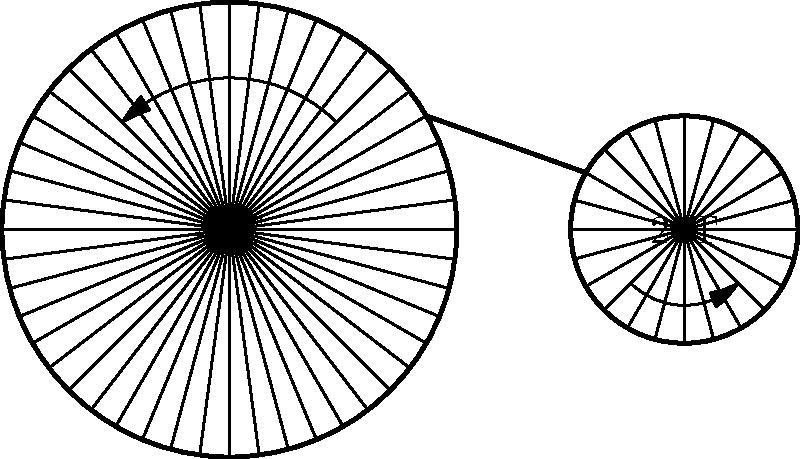Given the bicycle gear system shown in the schematic, with a 48-tooth chainring and a 24-tooth rear sprocket, calculate the gear ratio. How would this ratio affect a cyclist's performance on a flat road versus a steep climb? To solve this problem, let's follow these steps:

1. Calculate the gear ratio:
   The gear ratio is determined by dividing the number of teeth on the chainring by the number of teeth on the rear sprocket.

   Gear ratio = $\frac{\text{Teeth on chainring}}{\text{Teeth on rear sprocket}} = \frac{48}{24} = 2$

2. Understand the meaning of the gear ratio:
   A gear ratio of 2 means that for every complete revolution of the pedals (chainring), the rear wheel will rotate twice.

3. Effect on flat road:
   - Higher gear ratios provide more speed for each pedal revolution.
   - On a flat road, a 2:1 ratio would allow the cyclist to maintain high speeds with less cadence (pedaling frequency).
   - This is beneficial for experienced riders who can generate significant power.

4. Effect on steep climb:
   - Higher gear ratios require more force to turn the pedals.
   - On a steep climb, a 2:1 ratio would be challenging as it requires more strength per pedal stroke.
   - Climbers often prefer lower gear ratios (closer to 1:1) for easier pedaling on inclines.

5. Optimal use:
   - This gear ratio (2:1) is versatile for strong riders on varied terrain.
   - It's suitable for flat roads and moderate hills but may be too high for very steep climbs.
   - Elite cyclists might use this ratio for time trials or when high speed is prioritized over ease of pedaling.

In conclusion, while this gear ratio offers speed advantages on flat terrain, it may not be optimal for steep climbs where a lower ratio would provide easier pedaling and better power management.
Answer: Gear ratio: 2:1. Favors speed on flats, challenging on steep climbs. 